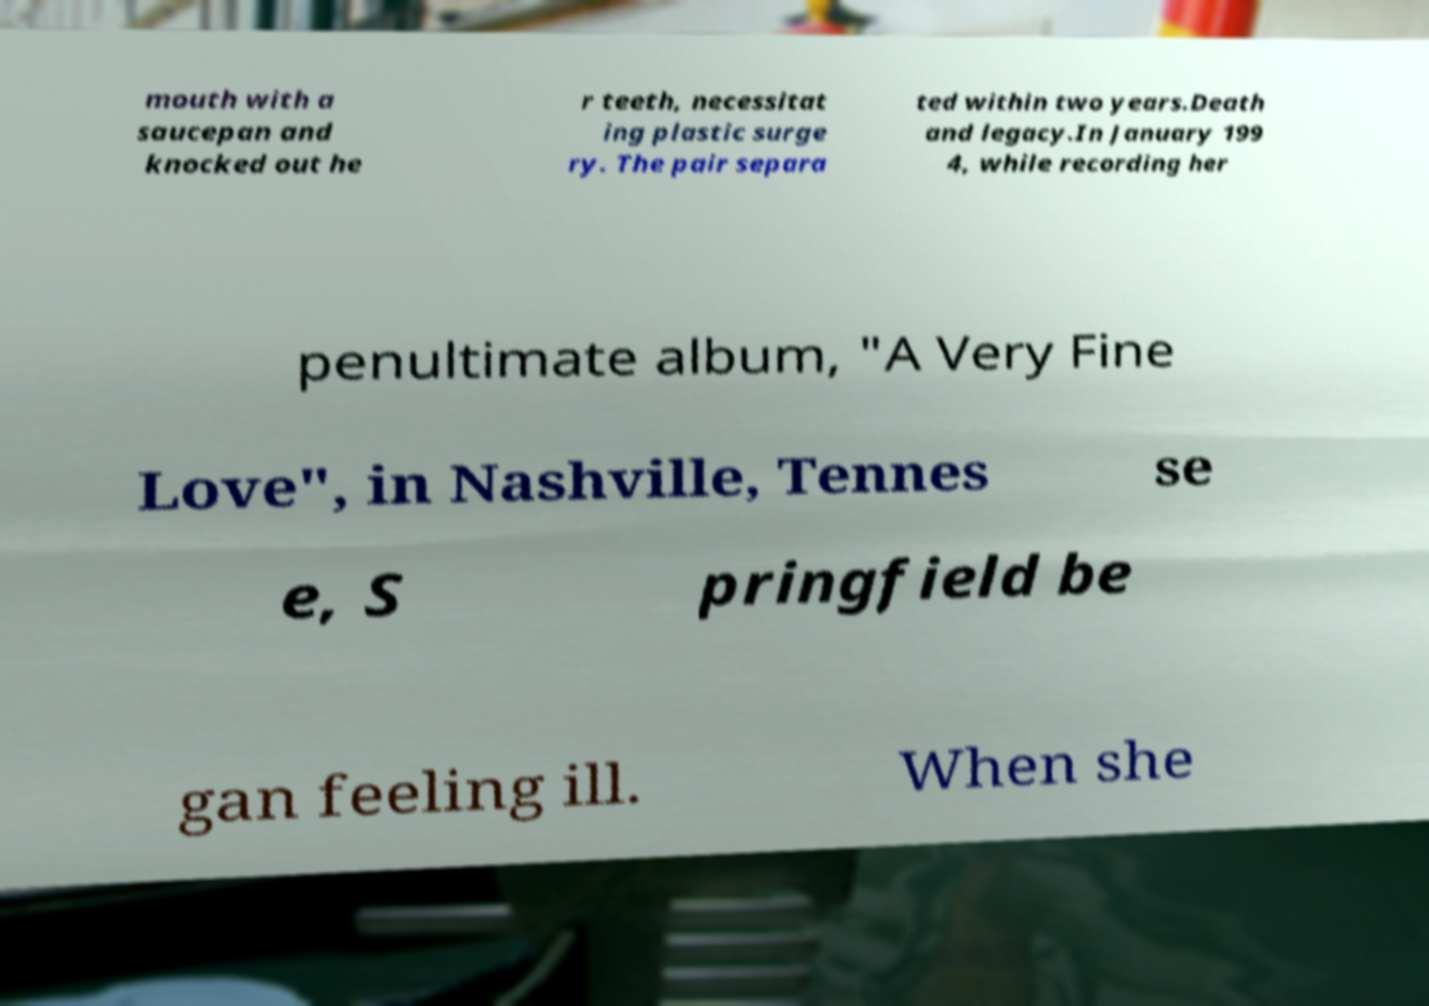Could you assist in decoding the text presented in this image and type it out clearly? mouth with a saucepan and knocked out he r teeth, necessitat ing plastic surge ry. The pair separa ted within two years.Death and legacy.In January 199 4, while recording her penultimate album, "A Very Fine Love", in Nashville, Tennes se e, S pringfield be gan feeling ill. When she 